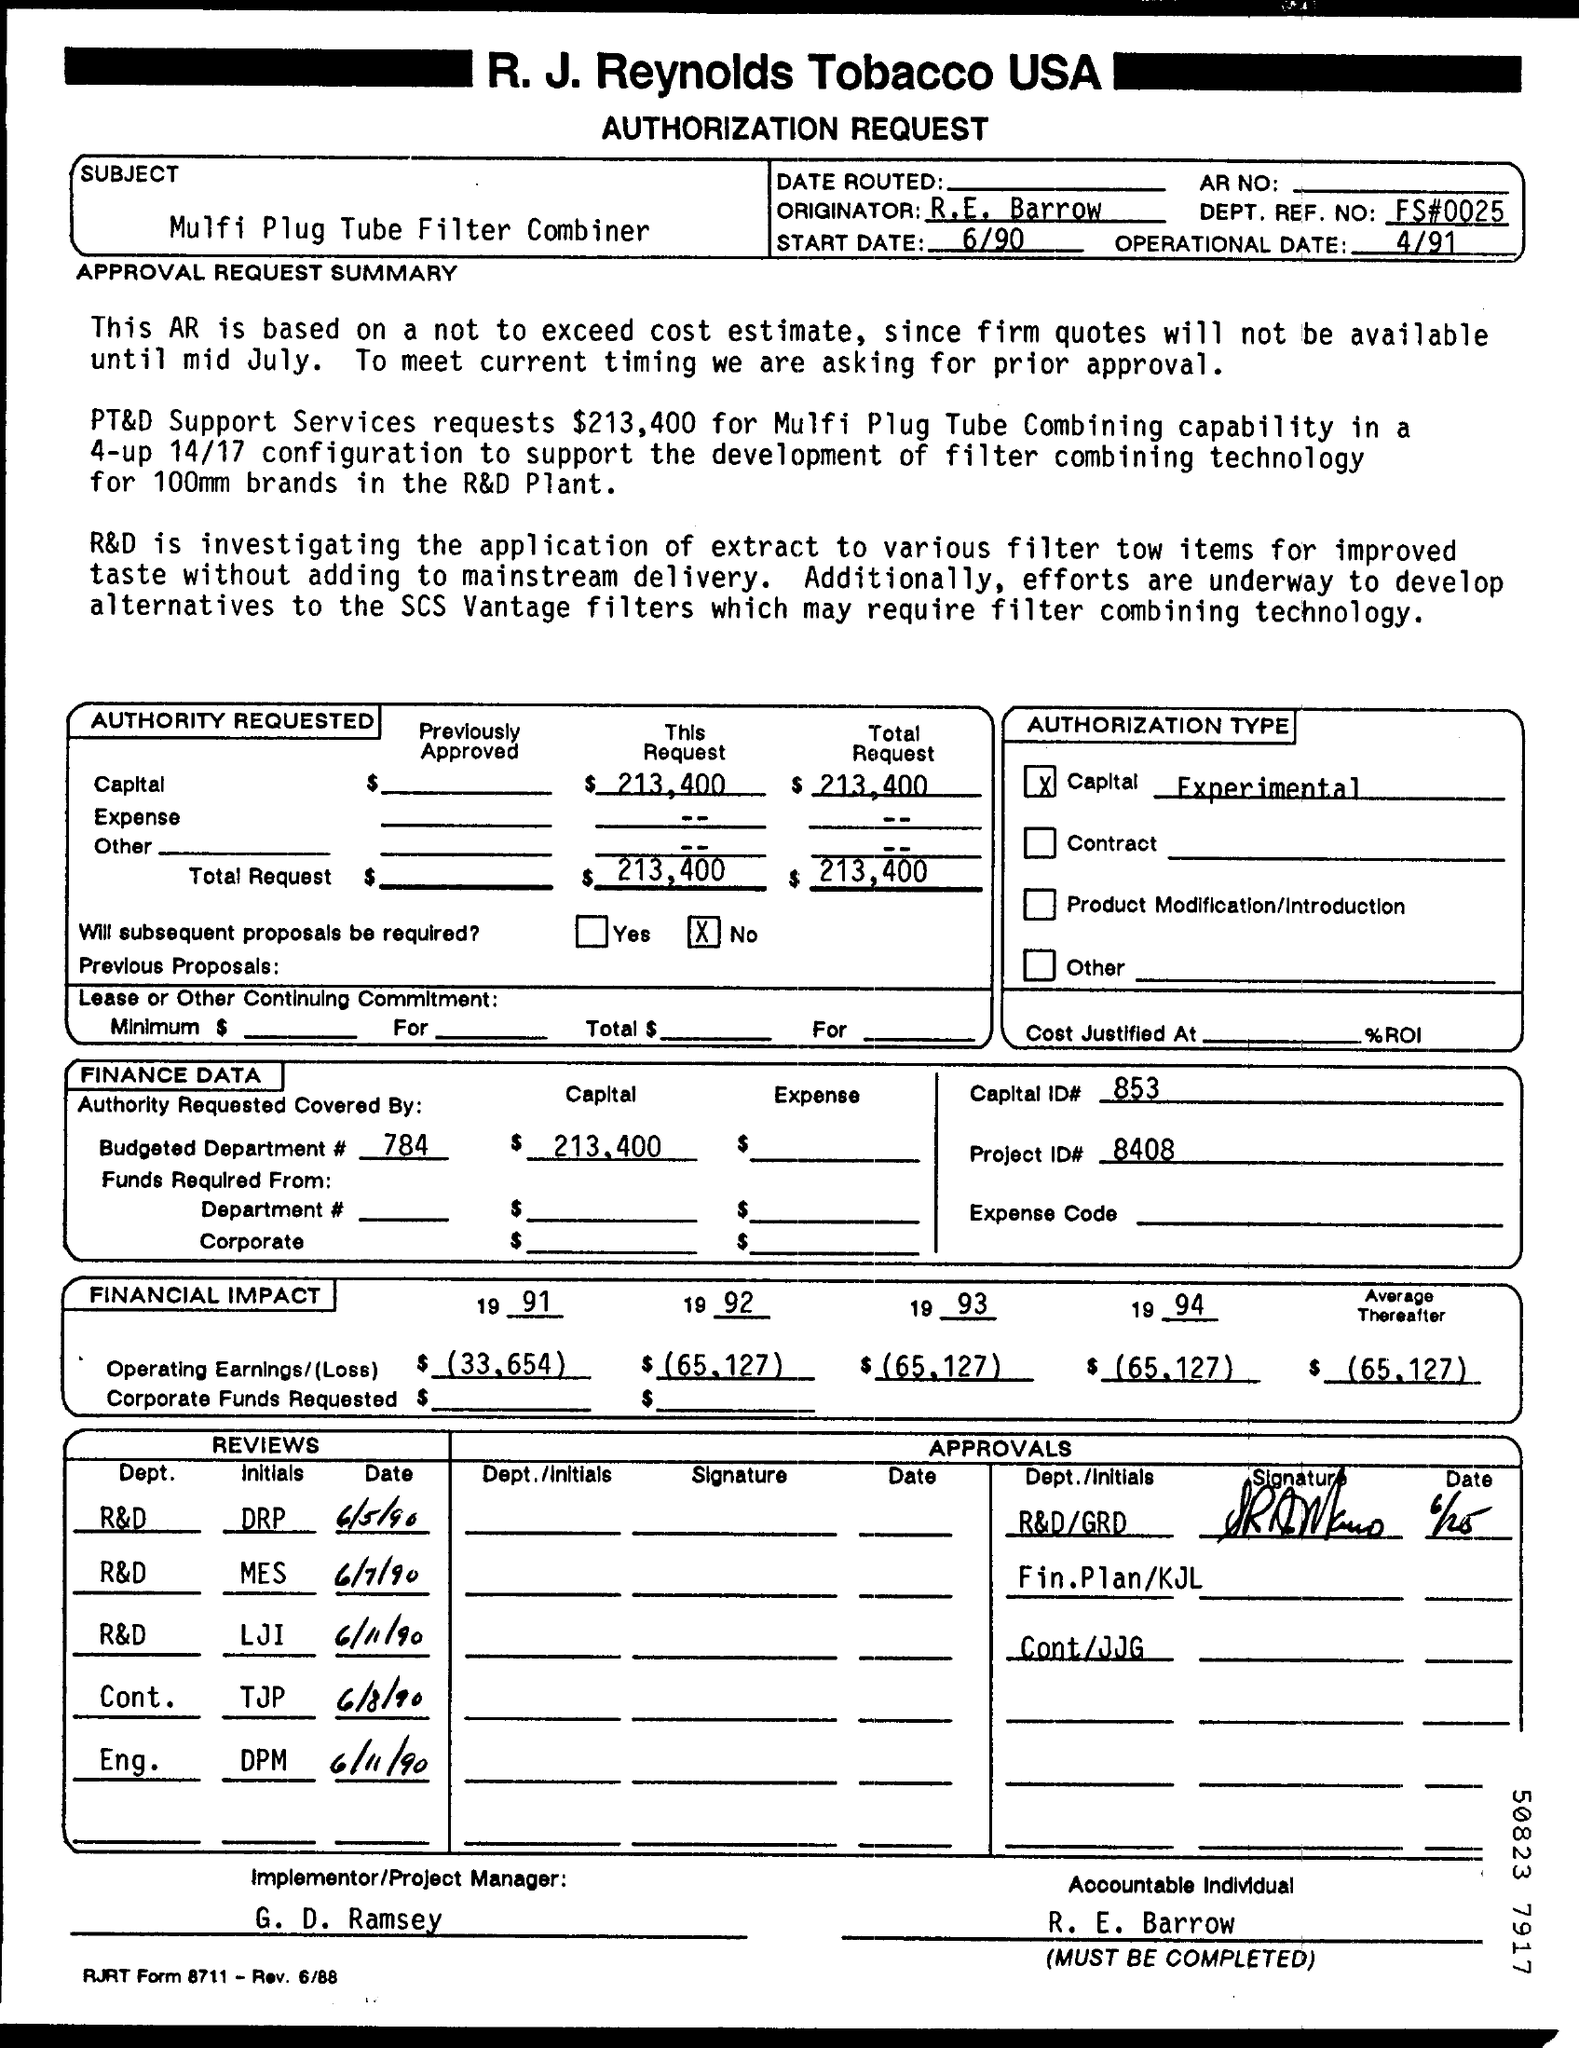What is the Subject of this request form
Your response must be concise. MULFI PLUG TUBE FILTER COMBINER. What is the DEPT. REF. NO of this Request form
Ensure brevity in your answer.  FS#0025. Who is the Implementer/Project Manager
Provide a short and direct response. G. D. RAMSEY. 